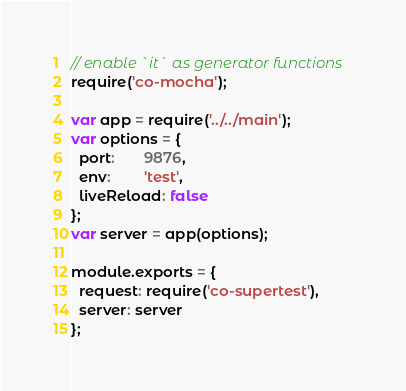Convert code to text. <code><loc_0><loc_0><loc_500><loc_500><_JavaScript_>// enable `it` as generator functions
require('co-mocha');

var app = require('../../main');
var options = {
  port:       9876,
  env:        'test',
  liveReload: false
};
var server = app(options);

module.exports = {
  request: require('co-supertest'),
  server: server
};
</code> 